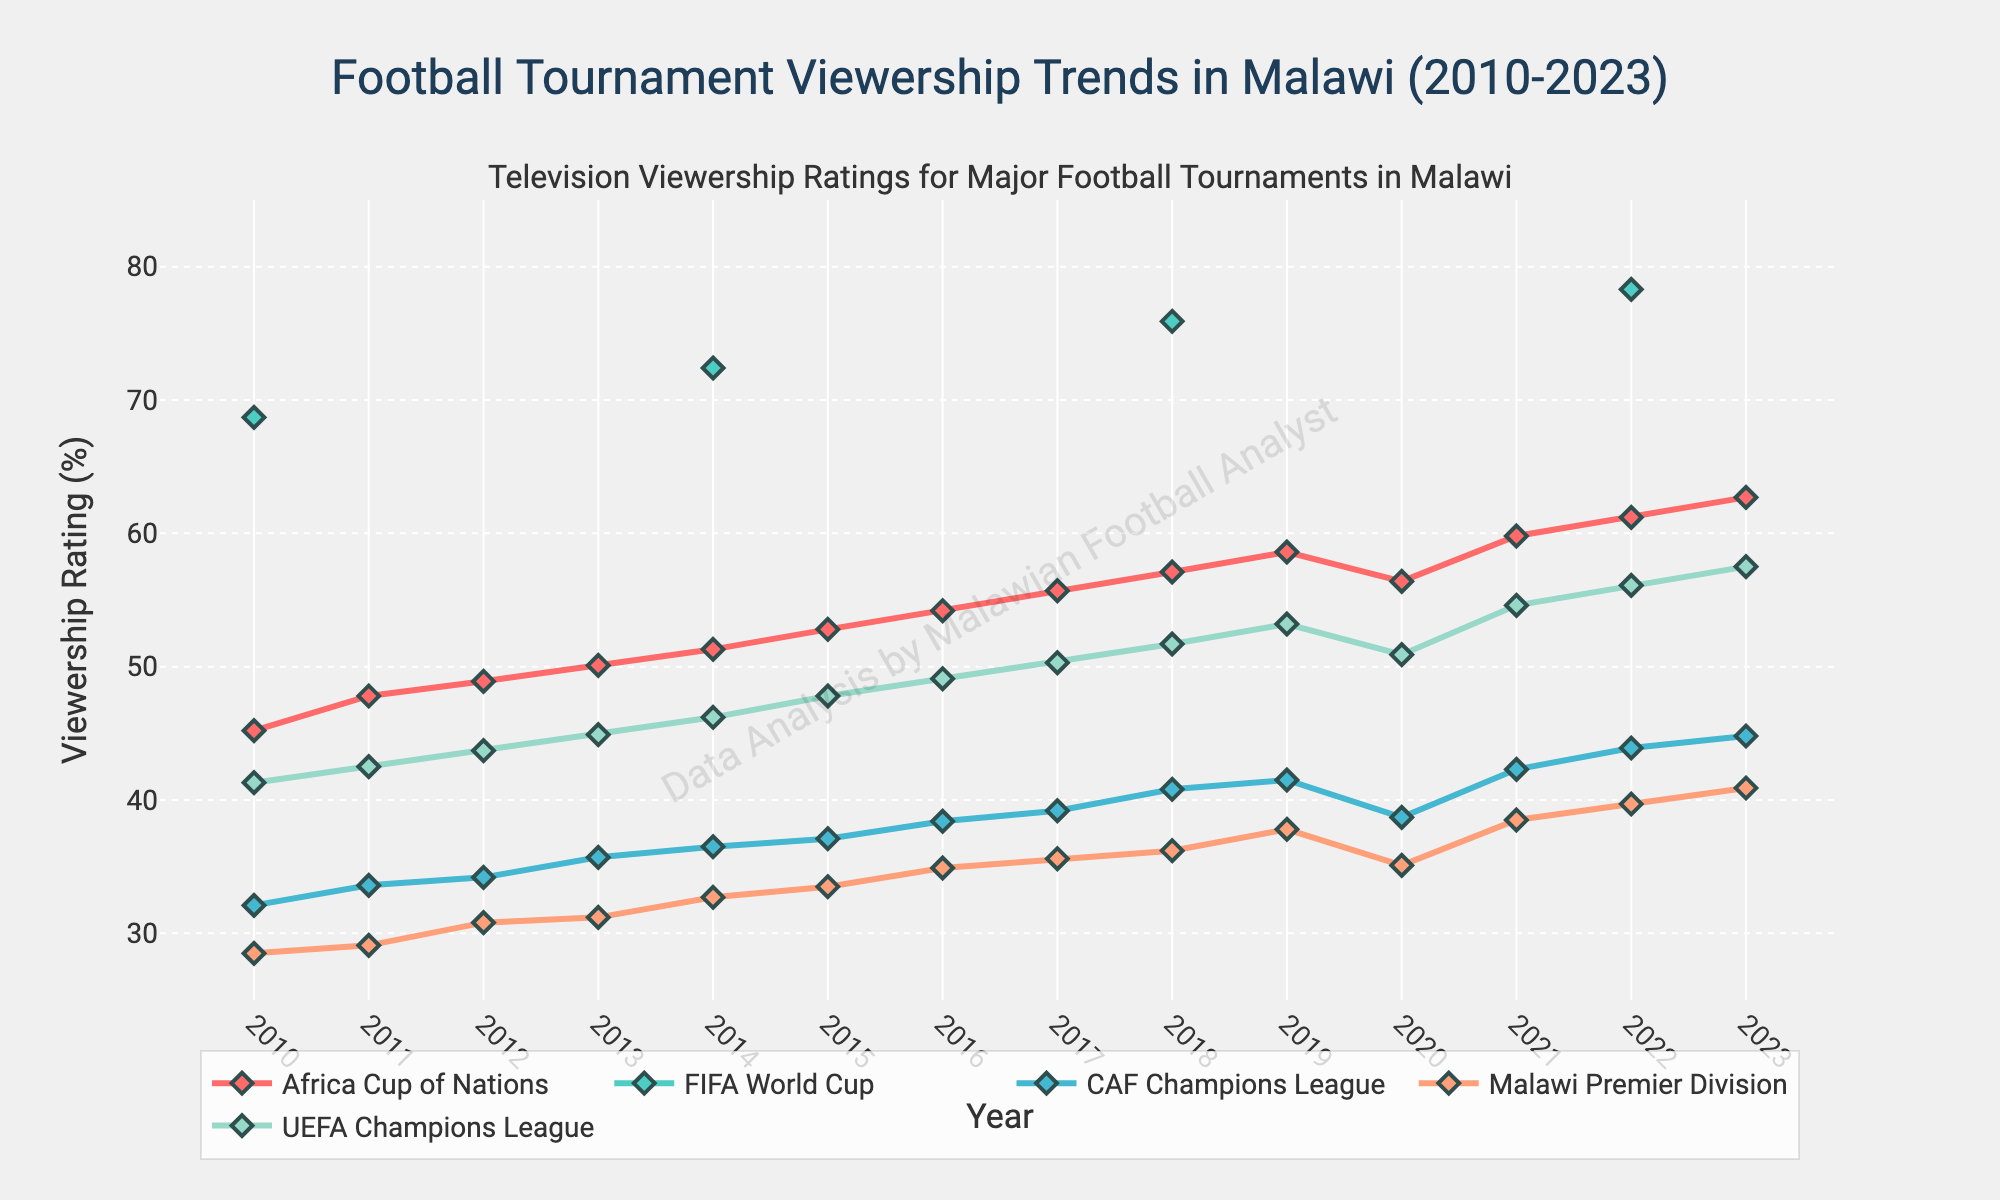What is the overall trend in viewership ratings for the Africa Cup of Nations from 2010 to 2023? Viewership ratings for the Africa Cup of Nations steadily increase from 45.2% in 2010 to 62.7% in 2023.
Answer: Increasing Which tournament had the highest viewership rating in 2022? In 2022, the FIFA World Cup had the highest viewership rating at 78.3%.
Answer: FIFA World Cup What is the difference in viewership ratings between the Malawi Premier Division and CAF Champions League in 2023? In 2023, the Malawi Premier Division has a rating of 40.9%, and the CAF Champions League has 44.8%. The difference is 44.8% - 40.9% = 3.9%.
Answer: 3.9% How did the viewership for the UEFA Champions League change from 2010 to 2023? The viewership for the UEFA Champions League increased from 41.3% in 2010 to 57.5% in 2023, showing a consistent upward trend.
Answer: Increased In which years did the Africa Cup of Nations viewership ratings increase by more than 2% compared to the previous year? The Africa Cup of Nations viewership ratings increased by more than 2% in 2011 with an increase of 2.6%, 2017 with an increase of 1.5%, and 2020 with a noticeable drop but immediately bouncing back in 2021 with an increase of 3.4%.
Answer: 2011, 2017, 2021 How did the viewership trend of the FIFA World Cup compare to the UEFA Champions League in 2018? In 2018, the FIFA World Cup had a significant spike in viewership at 75.9%, whereas the UEFA Champions League had a more moderate increase to 51.7%.
Answer: FIFA World Cup had a higher increase What is the average viewership rating of the Malawi Premier Division from 2010 to 2023? Adding the ratings from 2010 to 2023 (28.5 + 29.1 + 30.8 + 31.2 + 32.7 + 33.5 + 34.9 + 35.6 + 36.2 + 37.8 + 35.1 + 38.5 + 39.7 + 40.9) equals 474.5, and dividing by the 14 years gives an average rating of 474.5 / 14 ≈ 33.9%.
Answer: 33.9% Based on the visual trends, which tournament consistently shows the highest and lowest viewership ratings over the years? The FIFA World Cup consistently shows the highest viewership ratings during the years it is held, and the Malawi Premier Division usually has the lowest viewership ratings in comparison to the other tournaments.
Answer: FIFA World Cup, Malawi Premier Division 